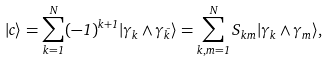<formula> <loc_0><loc_0><loc_500><loc_500>| c \rangle = \sum _ { k = 1 } ^ { N } ( - 1 ) ^ { k + 1 } | \gamma _ { k } \wedge \gamma _ { \bar { k } } \rangle = \sum _ { k , m = 1 } ^ { N } S _ { k m } | \gamma _ { k } \wedge \gamma _ { m } \rangle ,</formula> 